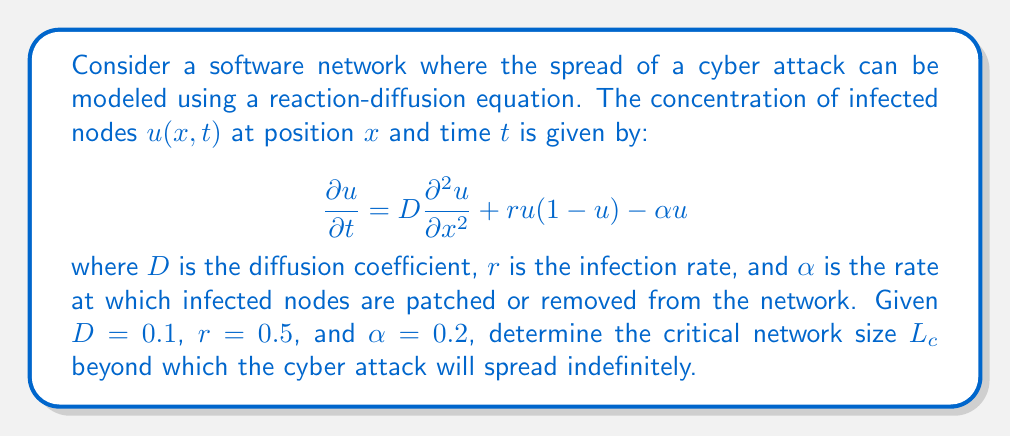Can you solve this math problem? To solve this problem, we need to analyze the stability of the steady-state solution. The critical network size is the threshold at which the system transitions from a stable (attack dies out) to an unstable (attack spreads) state.

1) First, we find the homogeneous steady-state solutions by setting $\frac{\partial u}{\partial t} = 0$ and $\frac{\partial^2 u}{\partial x^2} = 0$:

   $0 = ru(1-u) - \alpha u$

2) This gives us two solutions: $u=0$ and $u=1-\frac{\alpha}{r}$. We're interested in the stability of the $u=0$ solution (no infection).

3) To analyze stability, we introduce a small perturbation $\epsilon(x,t)$ to the $u=0$ solution:

   $u(x,t) = 0 + \epsilon(x,t)$

4) Substituting this into our original equation and linearizing:

   $\frac{\partial \epsilon}{\partial t} = D\frac{\partial^2 \epsilon}{\partial x^2} + (r-\alpha)\epsilon$

5) We look for solutions of the form $\epsilon(x,t) = e^{\lambda t}\cos(kx)$, where $k=\frac{n\pi}{L}$ for a network of size $L$. Substituting this in:

   $\lambda = -Dk^2 + (r-\alpha)$

6) The critical condition occurs when $\lambda = 0$ for the lowest non-zero mode ($n=1$):

   $0 = -D(\frac{\pi}{L_c})^2 + (r-\alpha)$

7) Solving for $L_c$:

   $L_c = \pi\sqrt{\frac{D}{r-\alpha}}$

8) Substituting the given values:

   $L_c = \pi\sqrt{\frac{0.1}{0.5-0.2}} = \pi\sqrt{\frac{0.1}{0.3}} \approx 3.62$
Answer: The critical network size is $L_c = \pi\sqrt{\frac{D}{r-\alpha}} \approx 3.62$ units. 